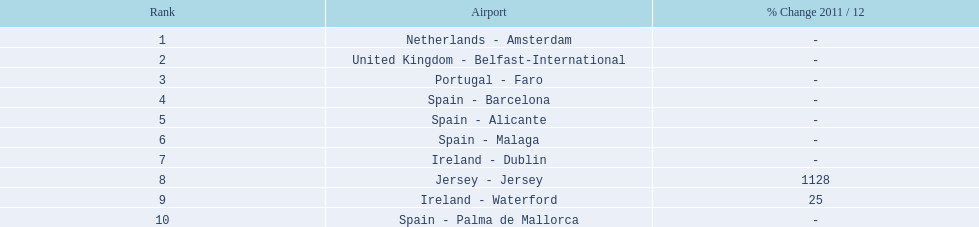What are the 10 busiest routes to and from london southend airport? Netherlands - Amsterdam, United Kingdom - Belfast-International, Portugal - Faro, Spain - Barcelona, Spain - Alicante, Spain - Malaga, Ireland - Dublin, Jersey - Jersey, Ireland - Waterford, Spain - Palma de Mallorca. Of these, which airport is in portugal? Portugal - Faro. 